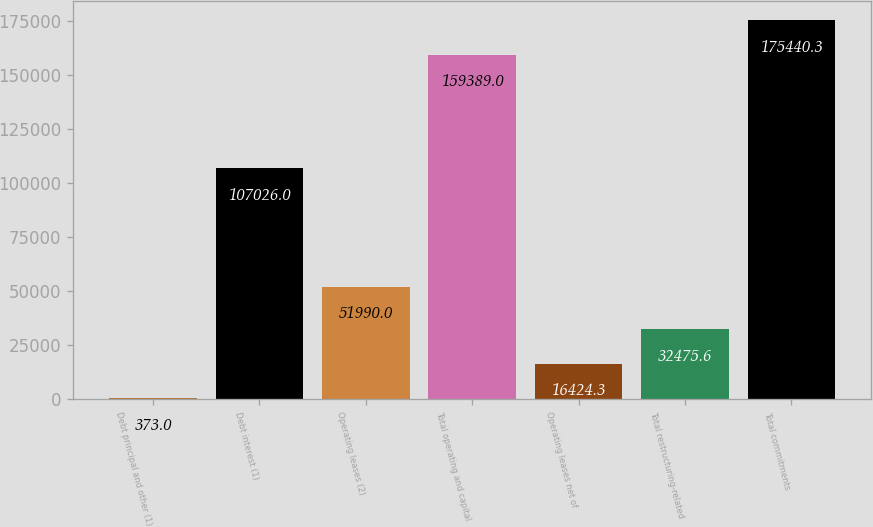Convert chart to OTSL. <chart><loc_0><loc_0><loc_500><loc_500><bar_chart><fcel>Debt principal and other (1)<fcel>Debt interest (1)<fcel>Operating leases (2)<fcel>Total operating and capital<fcel>Operating leases net of<fcel>Total restructuring-related<fcel>Total commitments<nl><fcel>373<fcel>107026<fcel>51990<fcel>159389<fcel>16424.3<fcel>32475.6<fcel>175440<nl></chart> 